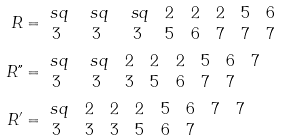Convert formula to latex. <formula><loc_0><loc_0><loc_500><loc_500>R & = \begin{matrix} \ s q & \ s q & \ s q & 2 & 2 & 2 & 5 & 6 \\ 3 & 3 & 3 & 5 & 6 & 7 & 7 & 7 \end{matrix} \\ R " & = \begin{matrix} \ s q & \ s q & 2 & 2 & 2 & 5 & 6 & 7 \\ 3 & 3 & 3 & 5 & 6 & 7 & 7 & \end{matrix} \\ R ^ { \prime } & = \begin{matrix} \ s q & 2 & 2 & 2 & 5 & 6 & 7 & 7 \\ 3 & 3 & 3 & 5 & 6 & 7 & & \end{matrix}</formula> 